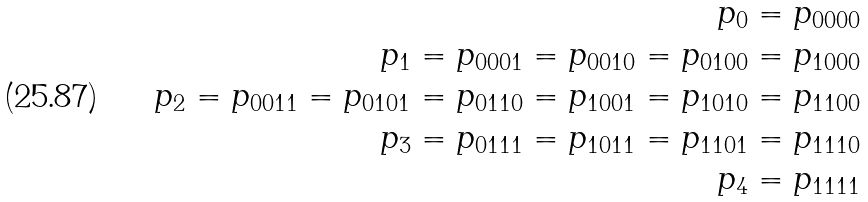Convert formula to latex. <formula><loc_0><loc_0><loc_500><loc_500>p _ { 0 } = p _ { 0 0 0 0 } \\ p _ { 1 } = p _ { 0 0 0 1 } = p _ { 0 0 1 0 } = p _ { 0 1 0 0 } = p _ { 1 0 0 0 } \\ p _ { 2 } = p _ { 0 0 1 1 } = p _ { 0 1 0 1 } = p _ { 0 1 1 0 } = p _ { 1 0 0 1 } = p _ { 1 0 1 0 } = p _ { 1 1 0 0 } \\ p _ { 3 } = p _ { 0 1 1 1 } = p _ { 1 0 1 1 } = p _ { 1 1 0 1 } = p _ { 1 1 1 0 } \\ p _ { 4 } = p _ { 1 1 1 1 }</formula> 